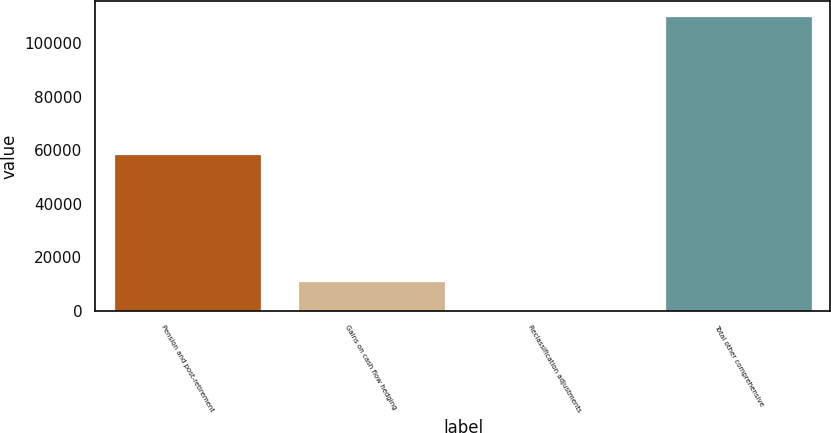Convert chart. <chart><loc_0><loc_0><loc_500><loc_500><bar_chart><fcel>Pension and post-retirement<fcel>Gains on cash flow hedging<fcel>Reclassification adjustments<fcel>Total other comprehensive<nl><fcel>58407<fcel>11176.7<fcel>173<fcel>110210<nl></chart> 